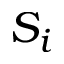<formula> <loc_0><loc_0><loc_500><loc_500>S _ { i }</formula> 